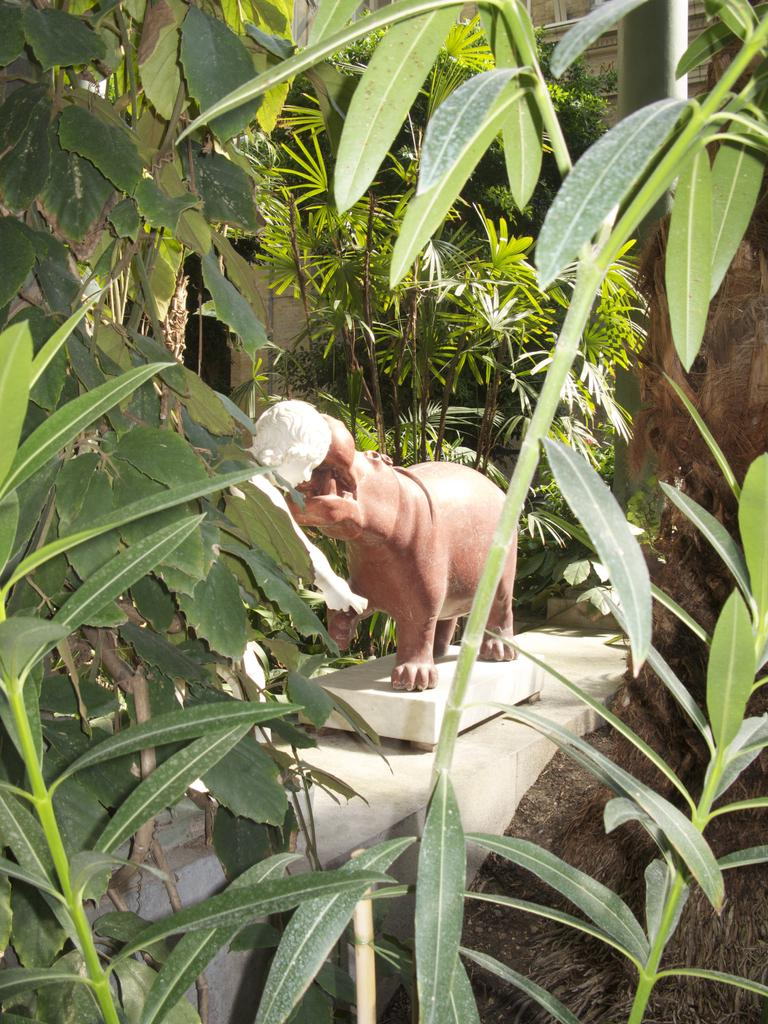What is the main subject of the image? There is a statue of an animal in the image. What type of vegetation can be seen in the image? There are green leaves visible in the image. What type of bells can be heard ringing in the image? There are no bells present in the image, and therefore no sound can be heard. What type of bone is visible in the image? There is no bone visible in the image; it features a statue of an animal and green leaves. 